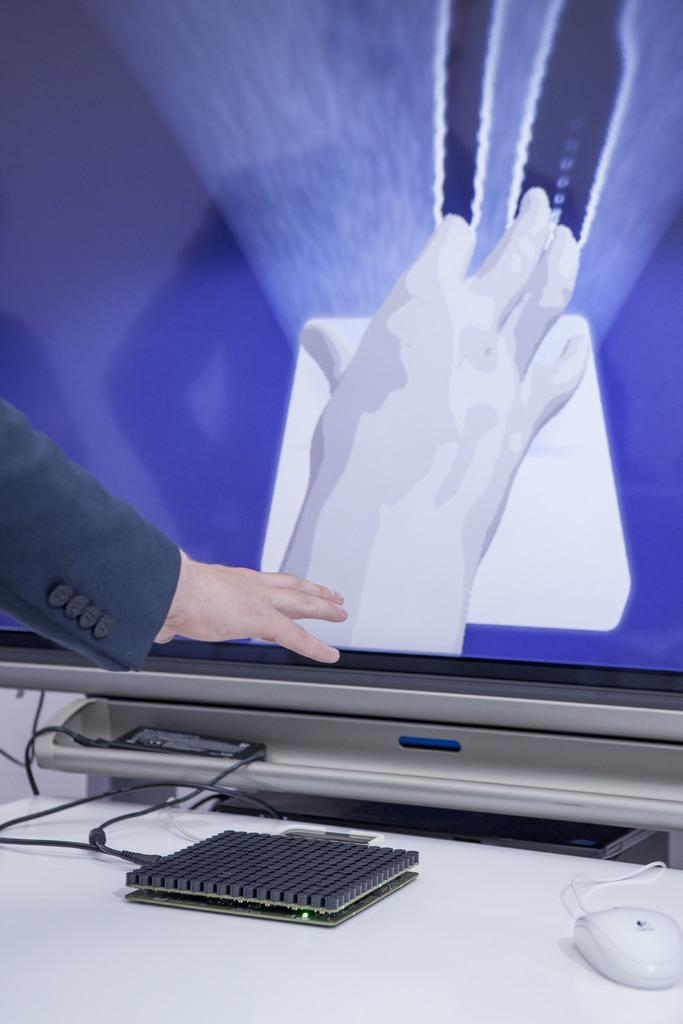What part of the body can be seen in the image? A hand is visible in the image. What type of clothing is depicted on the hand? There are gloves depicted in the painting. What is the dominant color of the painting? The painting is in blue color. What type of object can be seen in the image that has wires? There is a wired object in the image. What small animal is present in the image? A mouse is present in the image. What device with buttons can be seen in the image? A keypad is visible in the image. What type of anger can be seen on the face of the tramp in the image? There is no tramp or face present in the image; it features a hand with gloves, a blue painting, a wired object, a mouse, and a keypad. 